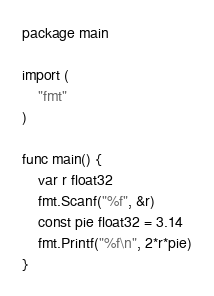Convert code to text. <code><loc_0><loc_0><loc_500><loc_500><_Go_>package main

import (
	"fmt"
)

func main() {
	var r float32
	fmt.Scanf("%f", &r)
	const pie float32 = 3.14
	fmt.Printf("%f\n", 2*r*pie)
}
</code> 